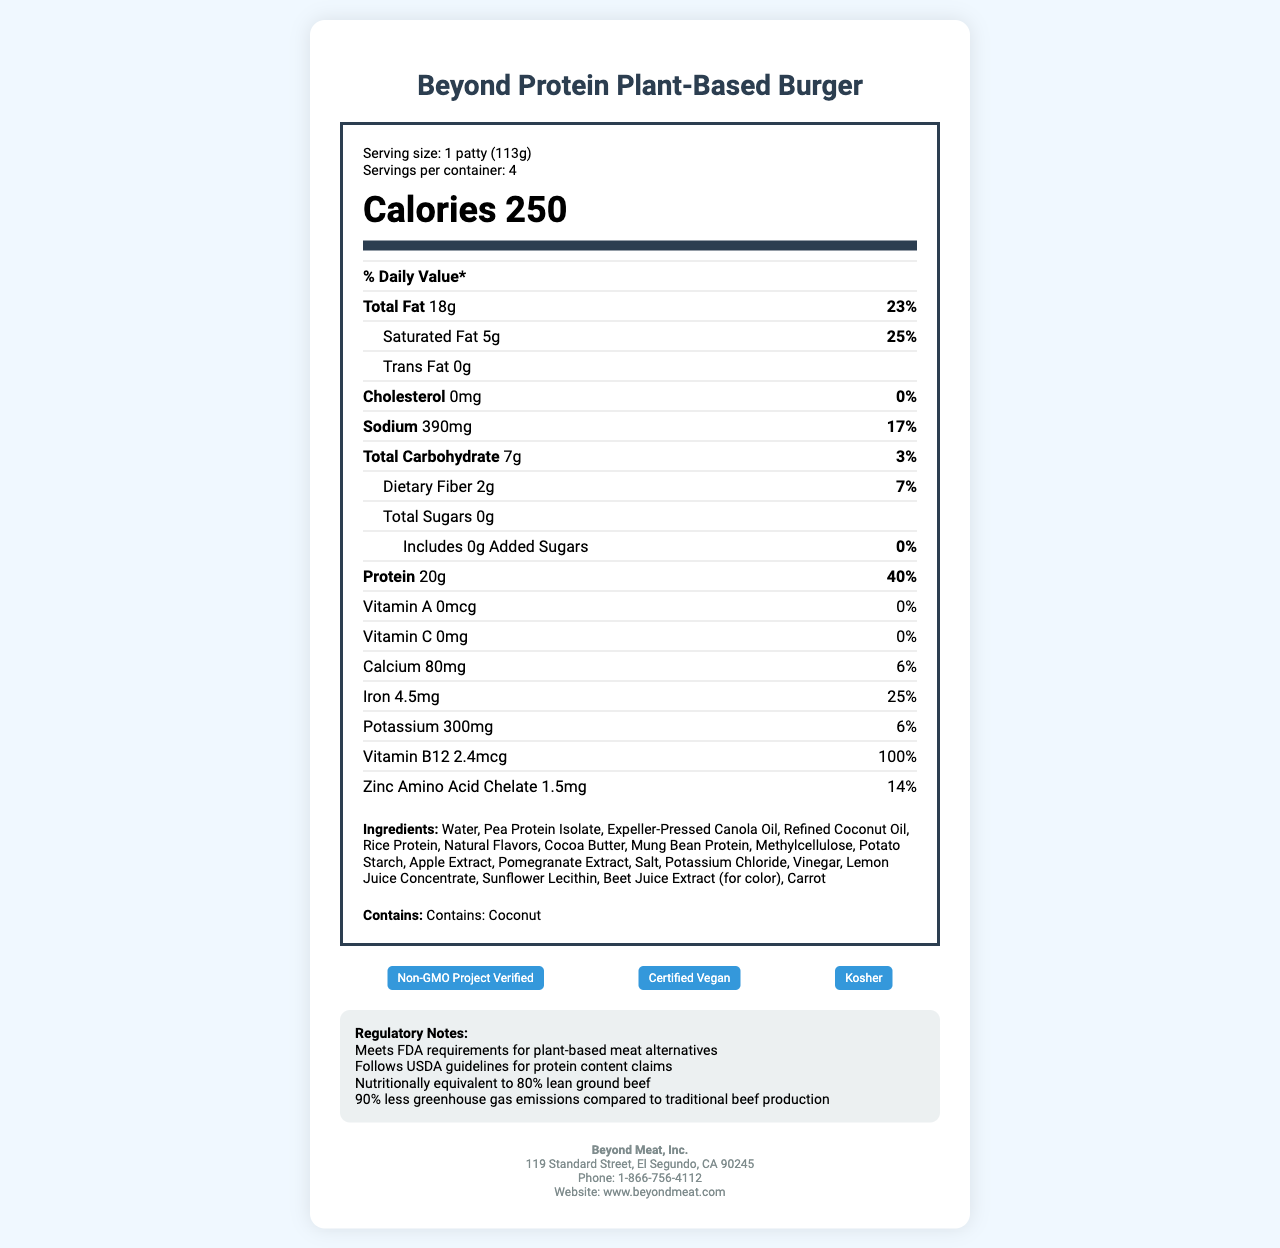what is the serving size of the Beyond Protein Plant-Based Burger? The serving size is listed at the top of the document under the product name.
Answer: 1 patty (113g) how many calories are in one serving of this product? The number of calories per serving is prominently displayed in the header section of the document.
Answer: 250 what is the daily value percentage for total fat? The daily value percentage is provided next to the total fat amount in the nutrient row.
Answer: 23% what amount of sodium is in one serving? The amount of sodium is listed in the nutrient row, along with its daily value percentage.
Answer: 390mg how many grams of protein does each serving contain? The protein content is clearly listed in the nutrient section, along with its daily value percentage.
Answer: 20g which vitamin has the highest daily value percentage? A. Vitamin A B. Vitamin C C. Vitamin B12 D. Calcium The document shows that Vitamin B12 has a daily value percentage of 100%, which is the highest among listed vitamins and minerals.
Answer: C what certifications does this product have? A. Non-GMO Project Verified B. Organic C. Certified Vegan D. Kosher The document lists Non-GMO Project Verified, Certified Vegan, and Kosher as the certifications.
Answer: A, C, D does the product contain any added sugars? The document shows that there are 0g of added sugars included.
Answer: No is this product compliant with FDA requirements for plant-based meat alternatives? True or False The regulatory notes section states that the product meets FDA requirements for plant-based meat alternatives.
Answer: True summarize the main points of the document. This summary highlights the key elements of the document, including nutritional value, compliance standards, environmental impact, and certifications.
Answer: The Beyond Protein Plant-Based Burger offers 20g of protein per serving and is a favorable alternative to traditional beef with 90% less greenhouse gas emissions. It is compliant with FDA and USDA guidelines, contains essential nutrients like iron and Vitamin B12, and is certified Non-GMO, vegan, and kosher. The product is allergen-free except for coconut. what is the address of the manufacturer's headquarters? The manufacturer's address is listed, but the question needs to be more specific regarding which details are required.
Answer: I don't know. does the product contain any allergens? The allergen statement at the bottom of the nutrient table states that the product contains coconut.
Answer: Yes, coconut how many servings are there per container? The document specifies that there are 4 servings per container.
Answer: 4 how much iron does each serving provide? The amount of iron per serving is provided in the nutrient section, along with its daily value percentage.
Answer: 4.5mg 